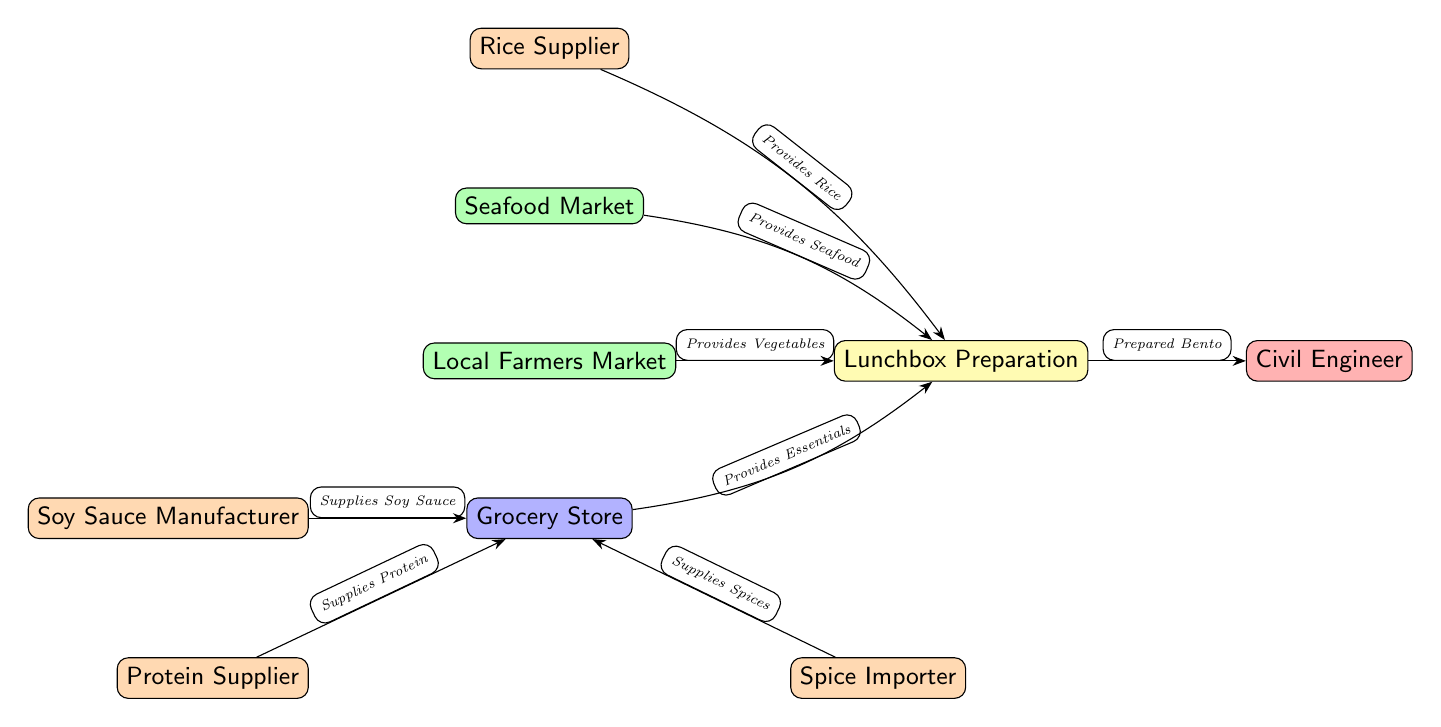What's the total number of nodes in the diagram? The diagram includes 8 distinct nodes: Rice Supplier, Seafood Market, Local Farmers Market, Grocery Store, Soy Sauce Manufacturer, Protein Supplier, Spice Importer, Lunchbox Preparation, and Civil Engineer. Counting each of these nodes gives us a total of 8.
Answer: 8 Which node supplies Soy Sauce? The diagram indicates that the Soy Sauce Manufacturer is directly connected to the Grocery Store, signifying that it is the source for soy sauce.
Answer: Soy Sauce Manufacturer What does the local farmers market provide? According to the diagram, the Local Farmers Market is linked to the Lunchbox Preparation node, denoting that it provides vegetables for the lunchbox.
Answer: Vegetables How many suppliers are present in the diagram? The diagram visually shows 4 nodes identified as suppliers: Rice Supplier, Soy Sauce Manufacturer, Protein Supplier, and Spice Importer. By counting these nodes, the total number of suppliers is confirmed.
Answer: 4 What is the final product prepared by the Lunchbox Preparation node? The diagram specifies that the Lunchbox Preparation node leads to the Civil Engineer node labeled as "Prepared Bento," indicating that this is the final product.
Answer: Prepared Bento Which market supplies seafood? The Seafood Market node, linked to the Lunchbox Preparation node, indicates that it is the source for seafood in the lunchbox.
Answer: Seafood Market What directly feeds into the Lunchbox Preparation? The Lunchbox Preparation node receives inputs from four different sources: Rice Supplier, Seafood Market, Local Farmers Market, and Grocery Store. Therefore, the answer to what feeds into it is these four suppliers.
Answer: Rice Supplier, Seafood Market, Local Farmers Market, Grocery Store Which node is connected to more than one supplier? The Grocery Store node is connected to three different suppliers: Soy Sauce Manufacturer, Protein Supplier, and Spice Importer, indicating that it receives supplies from multiple sources.
Answer: Grocery Store What is the role of the Civil Engineer in this diagram? The Civil Engineer node represents the end point of the diagram, where the final product, "Prepared Bento," is directed. This indicates that the civil engineer is the consumer of the product prepared from the inputs earlier in the flow.
Answer: Consumer 